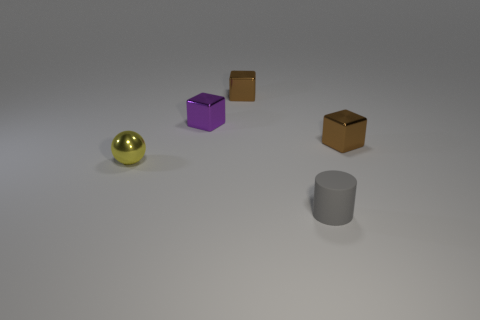Is there any other thing that has the same shape as the tiny yellow metallic object?
Provide a short and direct response. No. What material is the brown cube in front of the brown cube left of the tiny brown shiny object on the right side of the tiny gray matte cylinder?
Offer a terse response. Metal. How big is the brown metal block behind the tiny brown cube that is in front of the cube behind the small purple thing?
Offer a very short reply. Small. The gray thing on the left side of the brown object that is right of the tiny gray rubber cylinder is made of what material?
Ensure brevity in your answer.  Rubber. Does the small brown shiny thing left of the small cylinder have the same shape as the object in front of the yellow shiny object?
Keep it short and to the point. No. Are there the same number of small matte cylinders that are right of the cylinder and brown metal blocks?
Provide a succinct answer. No. There is a object in front of the tiny yellow shiny thing; is there a tiny brown block to the left of it?
Your answer should be very brief. Yes. Is there any other thing that has the same color as the cylinder?
Offer a very short reply. No. Does the tiny brown thing that is to the left of the small gray cylinder have the same material as the yellow ball?
Offer a very short reply. Yes. Is the number of things in front of the small purple metal cube the same as the number of blocks on the right side of the shiny ball?
Ensure brevity in your answer.  Yes. 